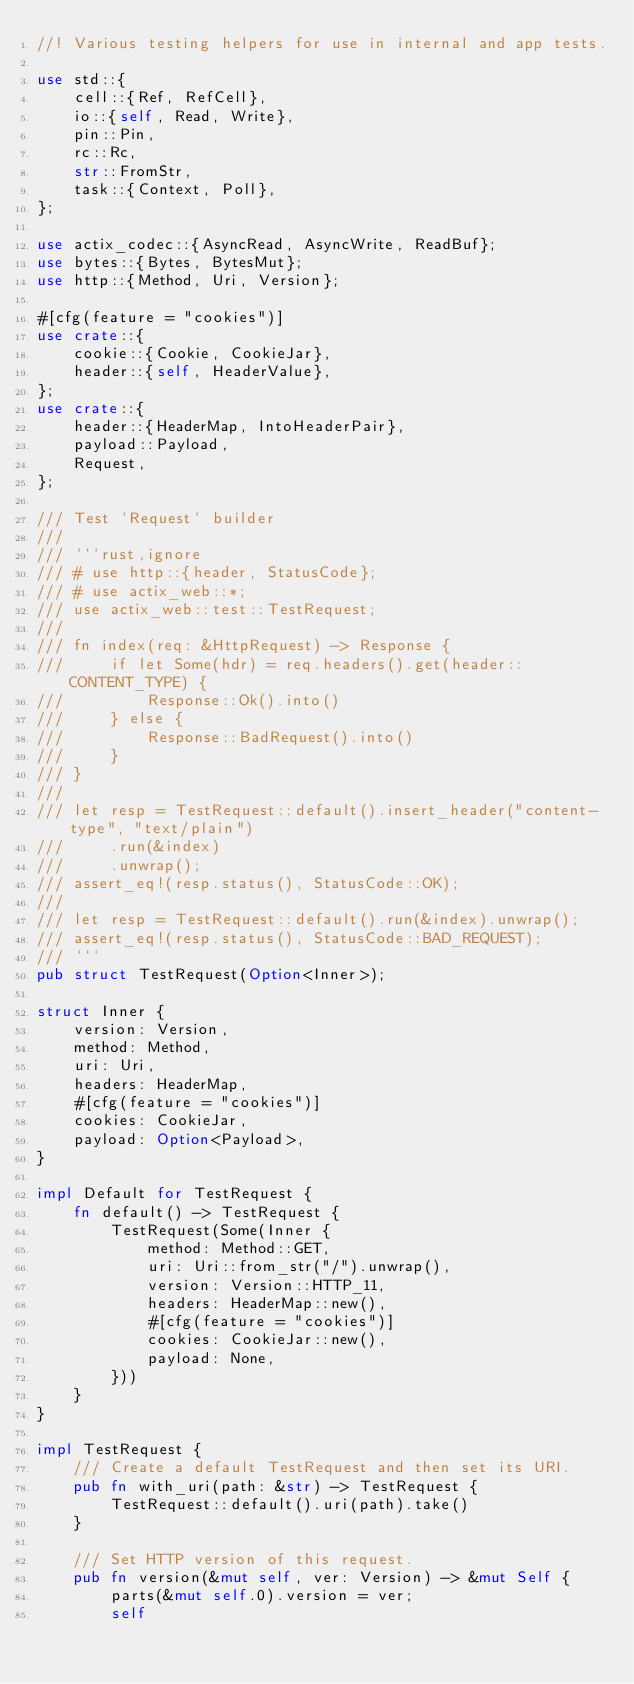<code> <loc_0><loc_0><loc_500><loc_500><_Rust_>//! Various testing helpers for use in internal and app tests.

use std::{
    cell::{Ref, RefCell},
    io::{self, Read, Write},
    pin::Pin,
    rc::Rc,
    str::FromStr,
    task::{Context, Poll},
};

use actix_codec::{AsyncRead, AsyncWrite, ReadBuf};
use bytes::{Bytes, BytesMut};
use http::{Method, Uri, Version};

#[cfg(feature = "cookies")]
use crate::{
    cookie::{Cookie, CookieJar},
    header::{self, HeaderValue},
};
use crate::{
    header::{HeaderMap, IntoHeaderPair},
    payload::Payload,
    Request,
};

/// Test `Request` builder
///
/// ```rust,ignore
/// # use http::{header, StatusCode};
/// # use actix_web::*;
/// use actix_web::test::TestRequest;
///
/// fn index(req: &HttpRequest) -> Response {
///     if let Some(hdr) = req.headers().get(header::CONTENT_TYPE) {
///         Response::Ok().into()
///     } else {
///         Response::BadRequest().into()
///     }
/// }
///
/// let resp = TestRequest::default().insert_header("content-type", "text/plain")
///     .run(&index)
///     .unwrap();
/// assert_eq!(resp.status(), StatusCode::OK);
///
/// let resp = TestRequest::default().run(&index).unwrap();
/// assert_eq!(resp.status(), StatusCode::BAD_REQUEST);
/// ```
pub struct TestRequest(Option<Inner>);

struct Inner {
    version: Version,
    method: Method,
    uri: Uri,
    headers: HeaderMap,
    #[cfg(feature = "cookies")]
    cookies: CookieJar,
    payload: Option<Payload>,
}

impl Default for TestRequest {
    fn default() -> TestRequest {
        TestRequest(Some(Inner {
            method: Method::GET,
            uri: Uri::from_str("/").unwrap(),
            version: Version::HTTP_11,
            headers: HeaderMap::new(),
            #[cfg(feature = "cookies")]
            cookies: CookieJar::new(),
            payload: None,
        }))
    }
}

impl TestRequest {
    /// Create a default TestRequest and then set its URI.
    pub fn with_uri(path: &str) -> TestRequest {
        TestRequest::default().uri(path).take()
    }

    /// Set HTTP version of this request.
    pub fn version(&mut self, ver: Version) -> &mut Self {
        parts(&mut self.0).version = ver;
        self</code> 